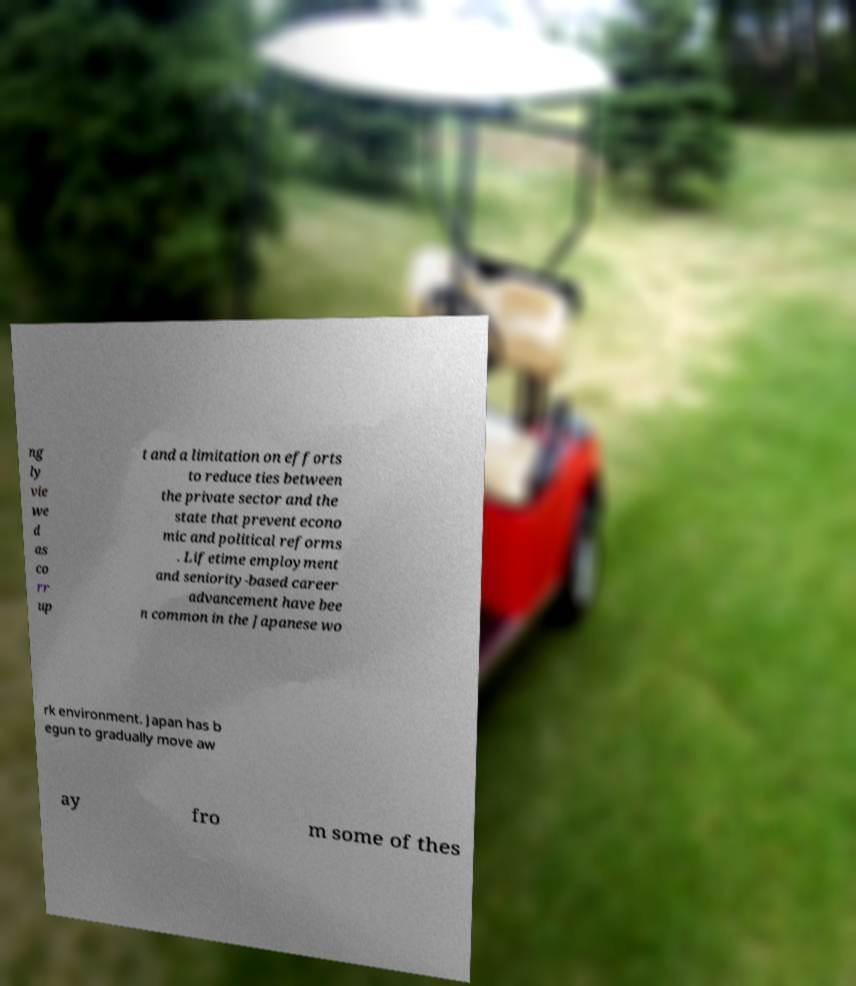Please identify and transcribe the text found in this image. ng ly vie we d as co rr up t and a limitation on efforts to reduce ties between the private sector and the state that prevent econo mic and political reforms . Lifetime employment and seniority-based career advancement have bee n common in the Japanese wo rk environment. Japan has b egun to gradually move aw ay fro m some of thes 